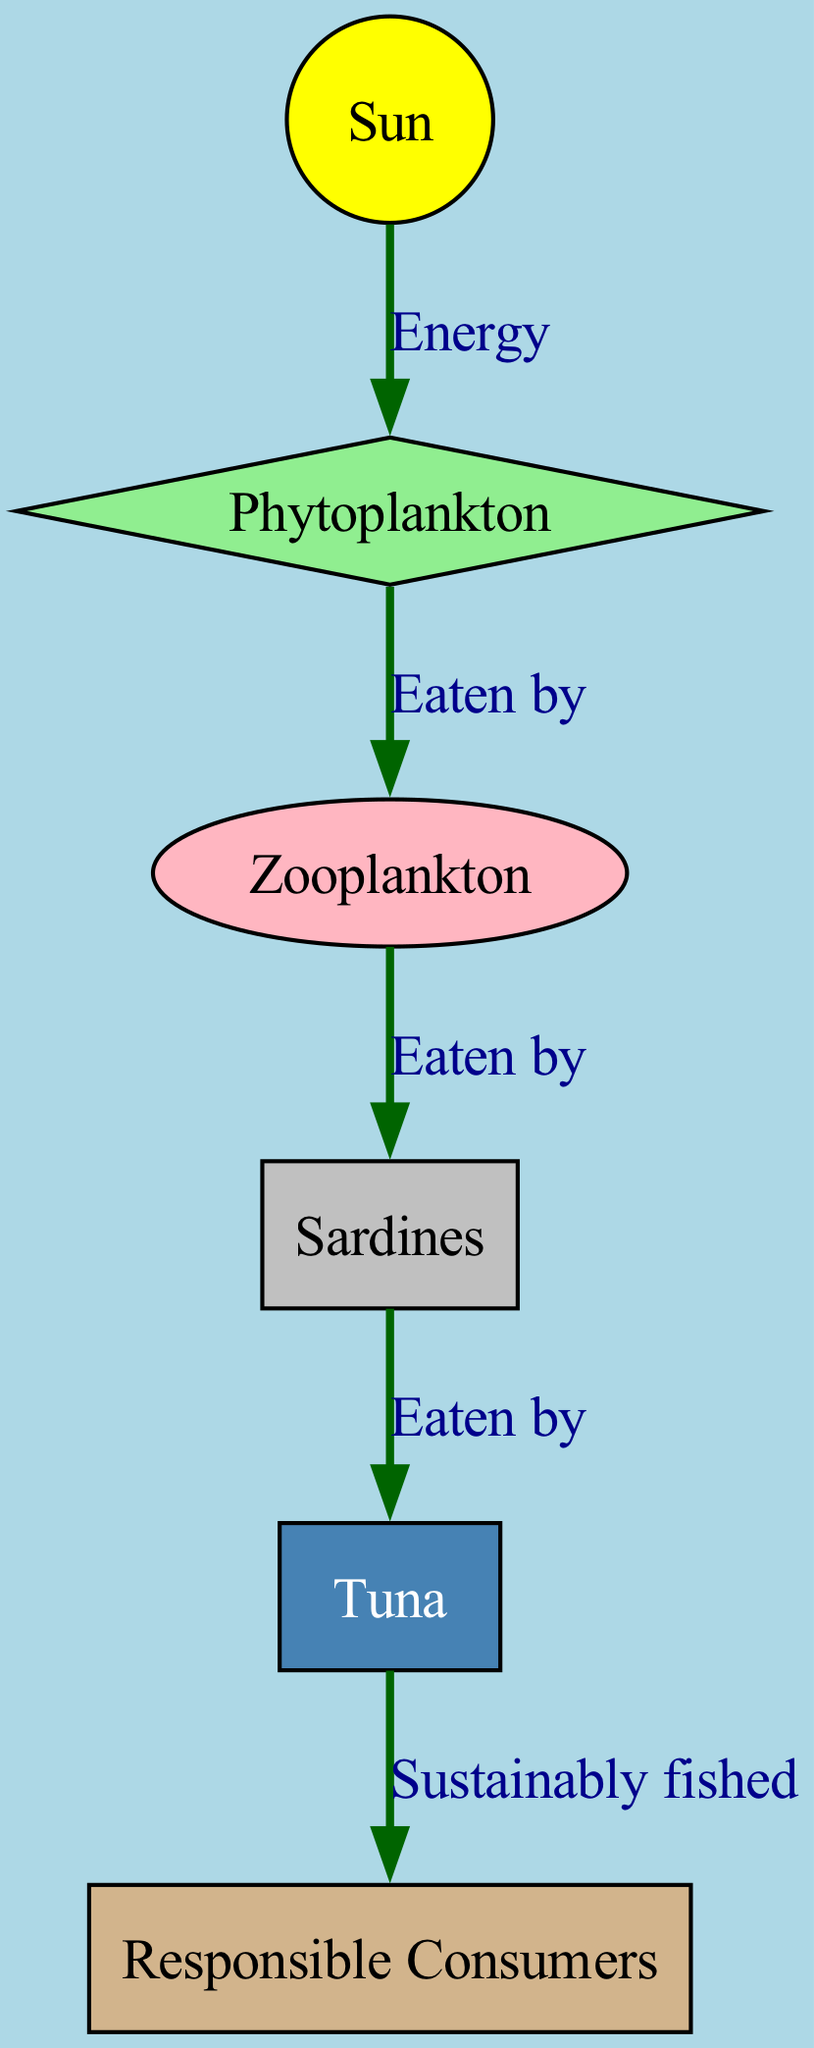What are the primary producers in this food chain? The primary producers are the organisms that convert sunlight into energy. In this diagram, it is represented by the "Phytoplankton" node, which directly receives energy from the "Sun."
Answer: Phytoplankton How many nodes are in the diagram? The number of nodes is calculated by counting each unique entity represented in the diagram. In this case, the nodes are: Sun, Phytoplankton, Zooplankton, Sardines, Tuna, and Responsible Consumers, totaling six nodes.
Answer: Six What is the relationship between Phytoplankton and Zooplankton? The diagram indicates that Zooplankton are "Eaten by" Phytoplankton, meaning that Phytoplankton serve as a food source for Zooplankton in the food chain.
Answer: Eaten by Which node is the top predator in this food chain? The top predator is determined by identifying which organism is at the top of the food chain. In this diagram, the "Tuna" is the apex predator as it is the last consumer before "Responsible Consumers."
Answer: Tuna How do humans interact with the marine food chain depicted here? In the diagram, "Humans" are connected to "Tuna" with the label "Sustainably fished," indicating that humans exploit tuna populations for food while considering sustainable practices in their fishing methods.
Answer: Sustainably fished How many edges connect the nodes in this diagram? The number of edges can be determined by counting the lines connecting the various nodes. The edges in this diagram include connections from Sun to Phytoplankton, Phytoplankton to Zooplankton, Zooplankton to Sardines, Sardines to Tuna, and Tuna to Responsible Consumers, totaling five edges.
Answer: Five What is the energy source that initiates this marine food chain? The energy source for the food chain is the "Sun," which is essential as it begins the energy transfer process to producers like phytoplankton.
Answer: Sun What types of organisms are represented by the nodes labelled "Sardines" and "Tuna"? The nodes represent fish organisms, with "Sardines" categorized as a type of forage fish that serve as prey, and "Tuna" as a larger predatory fish that feeds on smaller fish like sardines.
Answer: Fish 